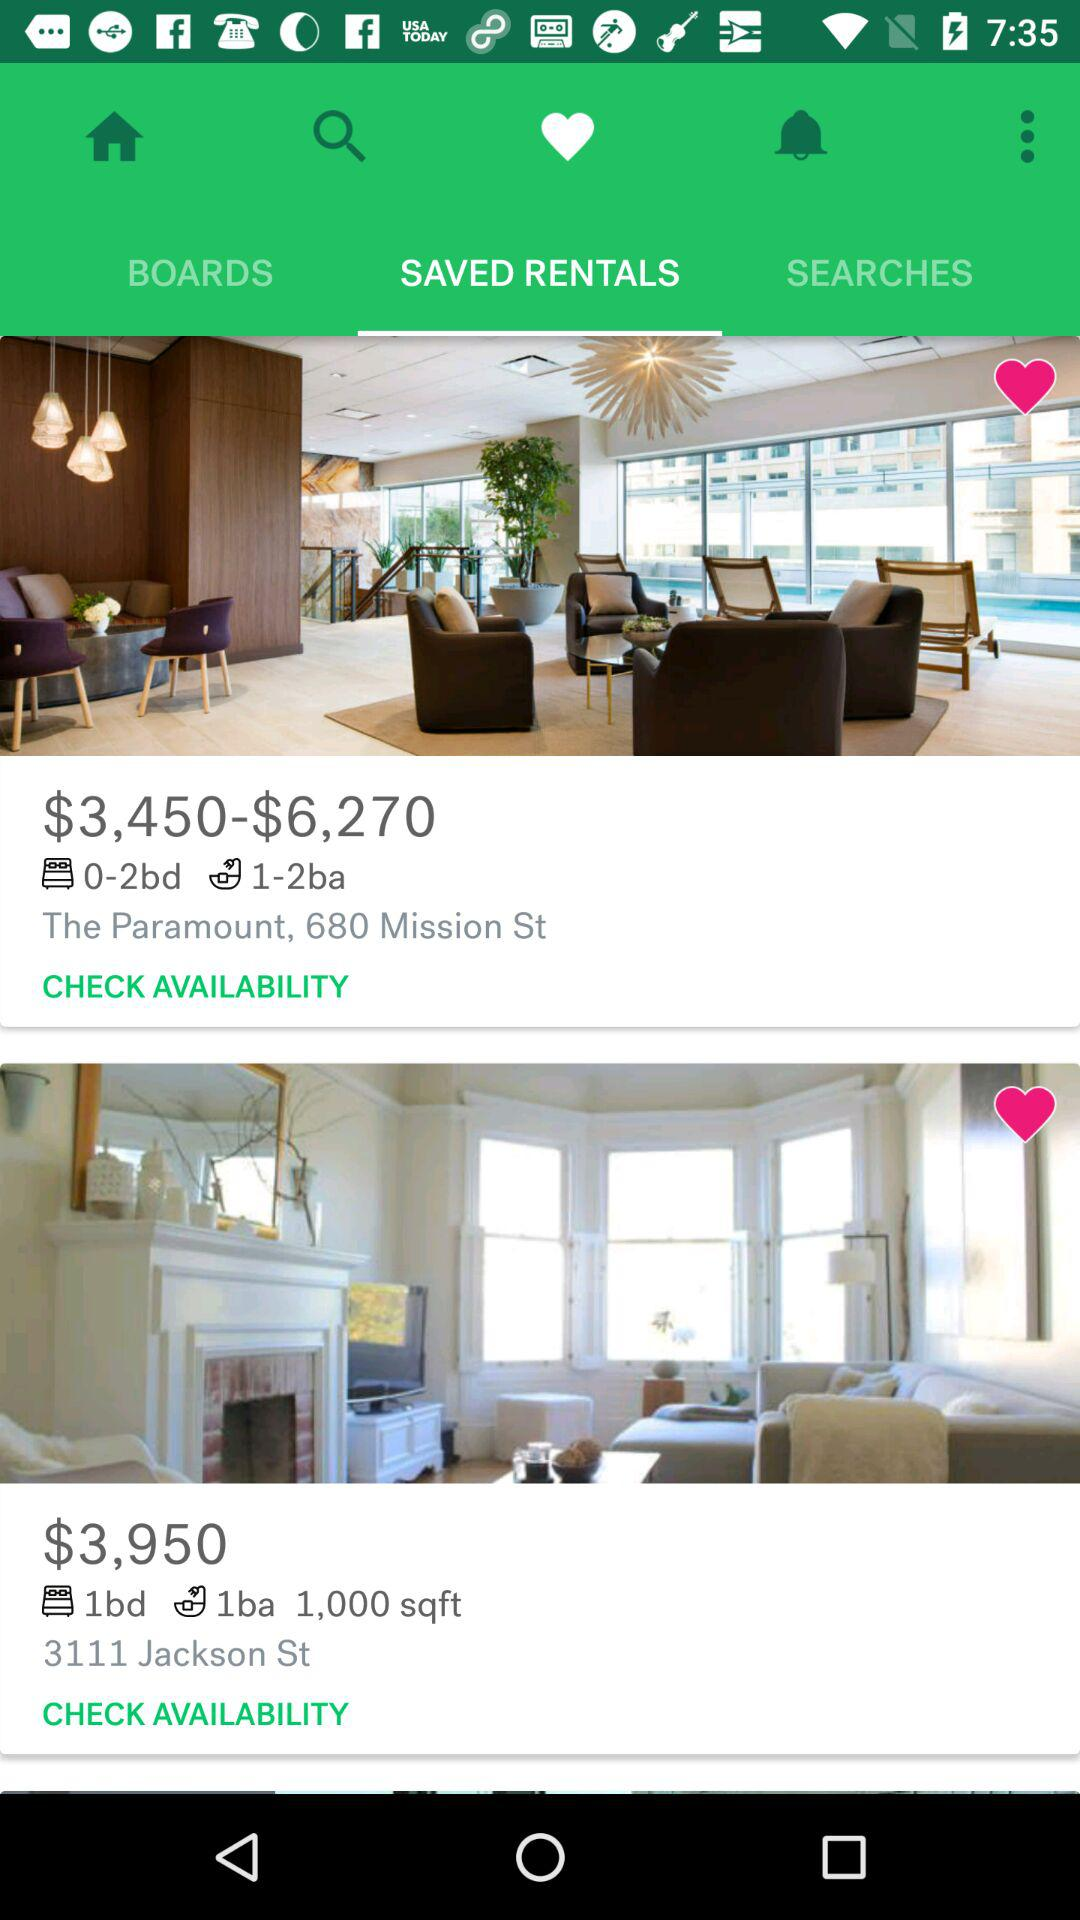What is the price of a 1,000-square-foot rental room? The price of a 1,000-square-foot rental room is $3,950. 